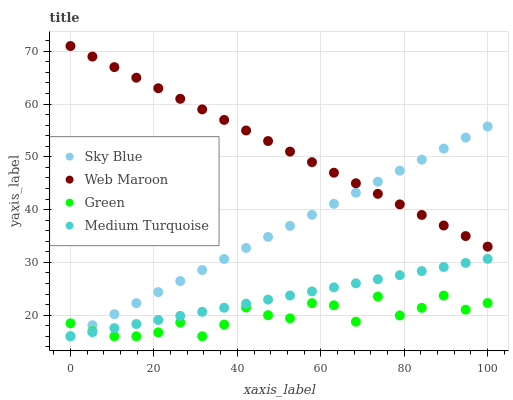Does Green have the minimum area under the curve?
Answer yes or no. Yes. Does Web Maroon have the maximum area under the curve?
Answer yes or no. Yes. Does Web Maroon have the minimum area under the curve?
Answer yes or no. No. Does Green have the maximum area under the curve?
Answer yes or no. No. Is Medium Turquoise the smoothest?
Answer yes or no. Yes. Is Green the roughest?
Answer yes or no. Yes. Is Web Maroon the smoothest?
Answer yes or no. No. Is Web Maroon the roughest?
Answer yes or no. No. Does Sky Blue have the lowest value?
Answer yes or no. Yes. Does Web Maroon have the lowest value?
Answer yes or no. No. Does Web Maroon have the highest value?
Answer yes or no. Yes. Does Green have the highest value?
Answer yes or no. No. Is Medium Turquoise less than Web Maroon?
Answer yes or no. Yes. Is Web Maroon greater than Green?
Answer yes or no. Yes. Does Green intersect Sky Blue?
Answer yes or no. Yes. Is Green less than Sky Blue?
Answer yes or no. No. Is Green greater than Sky Blue?
Answer yes or no. No. Does Medium Turquoise intersect Web Maroon?
Answer yes or no. No. 